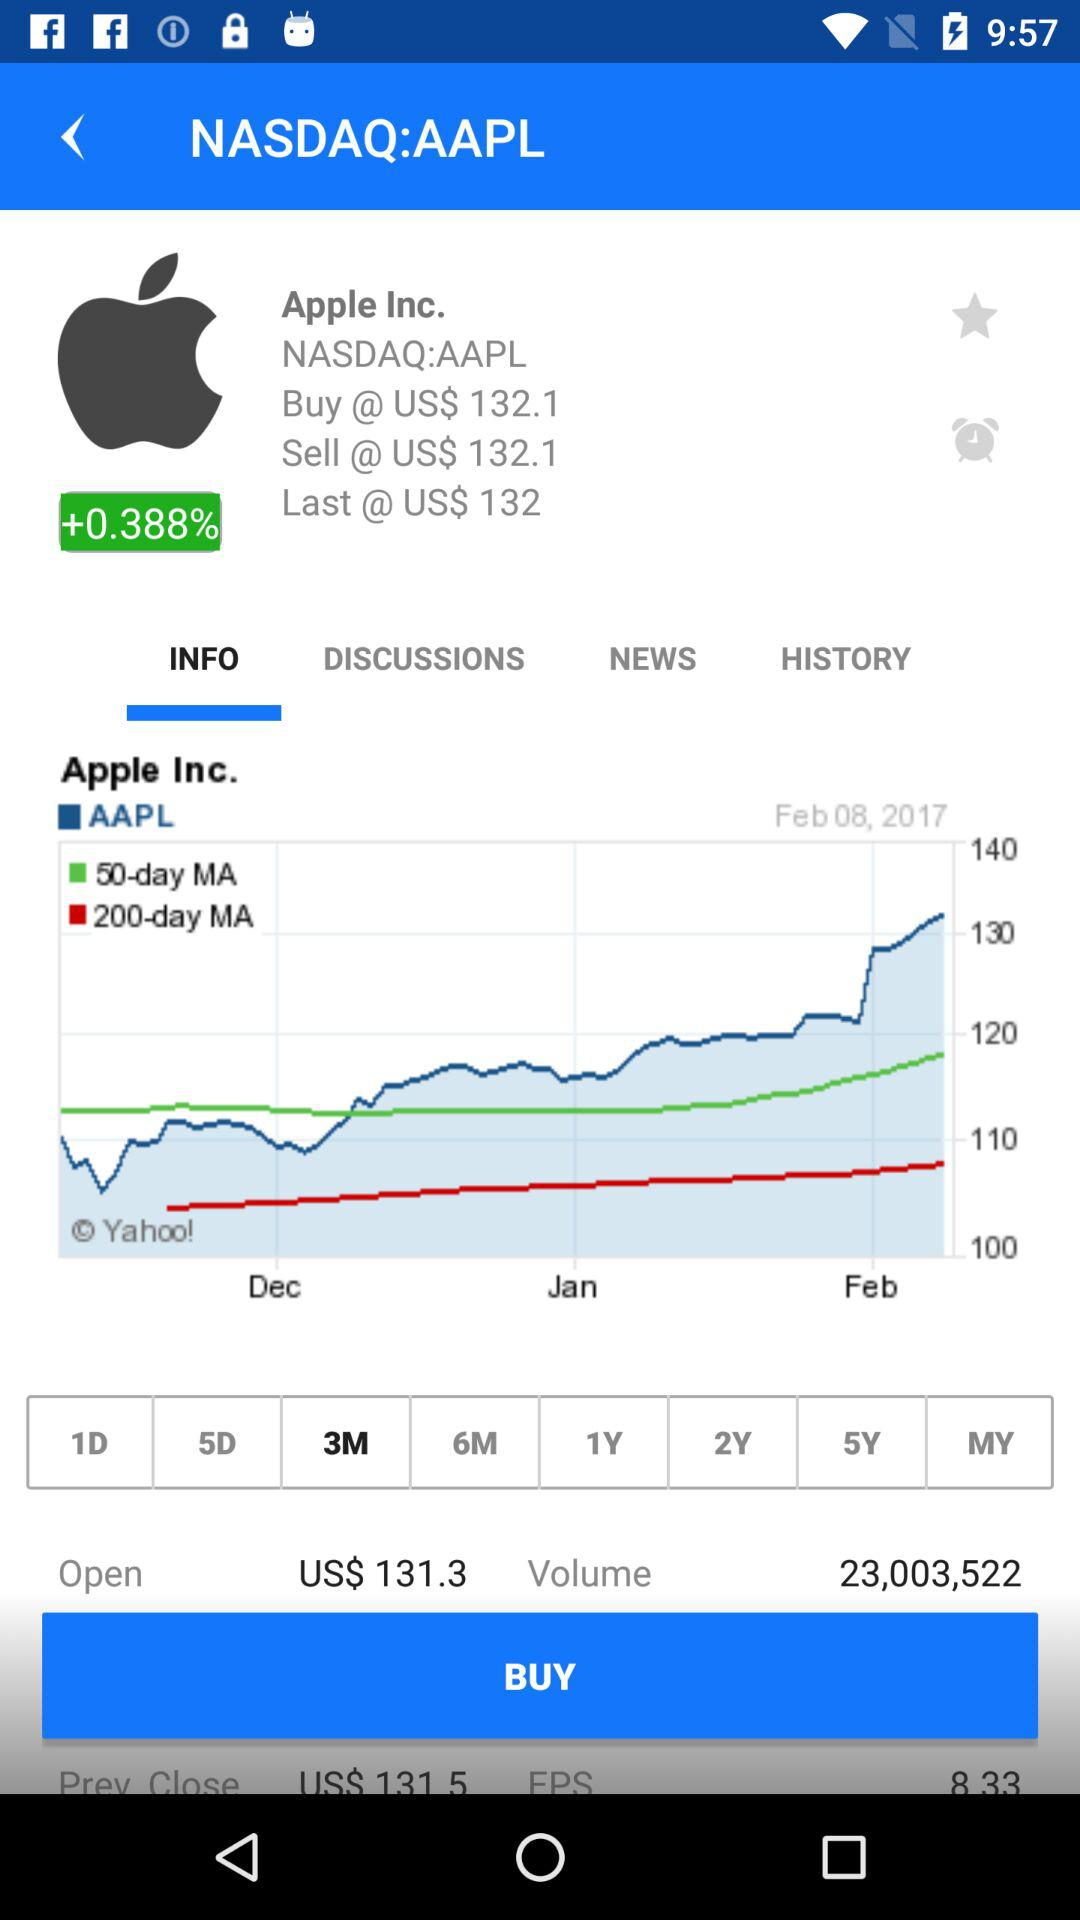What is the given open price? The given open price is US$ 131.3. 